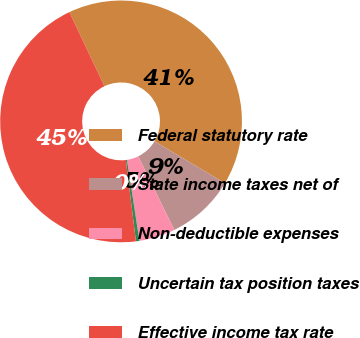Convert chart to OTSL. <chart><loc_0><loc_0><loc_500><loc_500><pie_chart><fcel>Federal statutory rate<fcel>State income taxes net of<fcel>Non-deductible expenses<fcel>Uncertain tax position taxes<fcel>Effective income tax rate<nl><fcel>40.57%<fcel>9.2%<fcel>4.83%<fcel>0.46%<fcel>44.94%<nl></chart> 